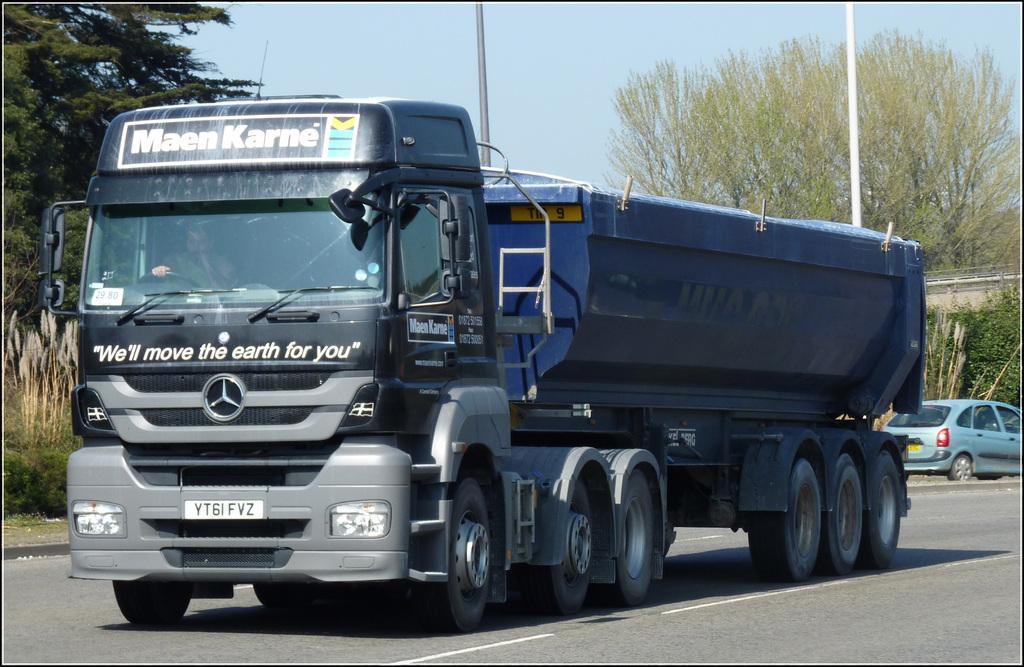Please provide a concise description of this image. In this image we can see a vehicle and a person inside it. On the vehicle we can see some text. Behind the vehicle we can see trees, poles and plants. On the right side, we can see a car, plants and a wall. At the top we can see the sky. 